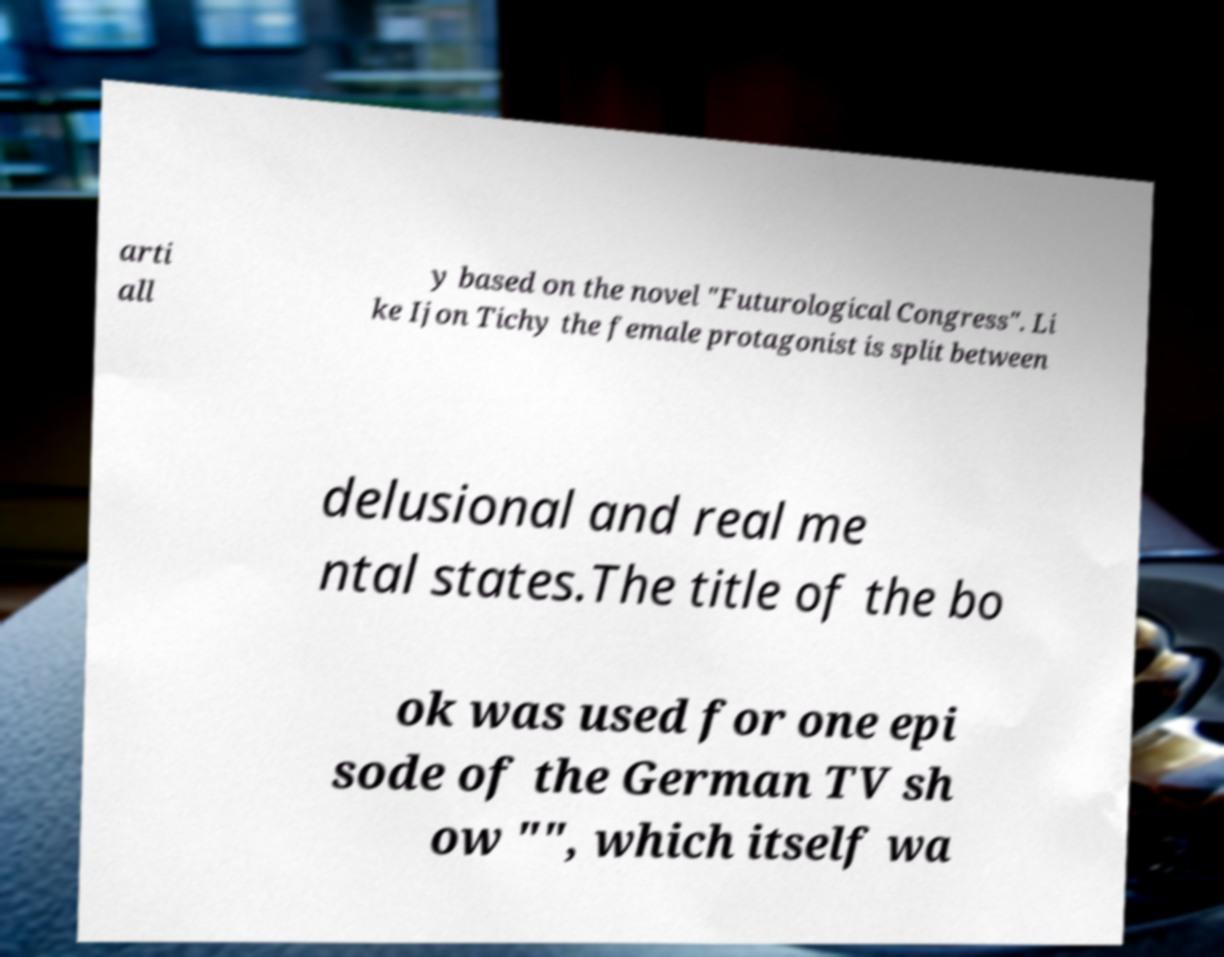Can you accurately transcribe the text from the provided image for me? arti all y based on the novel "Futurological Congress". Li ke Ijon Tichy the female protagonist is split between delusional and real me ntal states.The title of the bo ok was used for one epi sode of the German TV sh ow "", which itself wa 